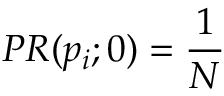Convert formula to latex. <formula><loc_0><loc_0><loc_500><loc_500>P R ( p _ { i } ; 0 ) = { \frac { 1 } { N } }</formula> 